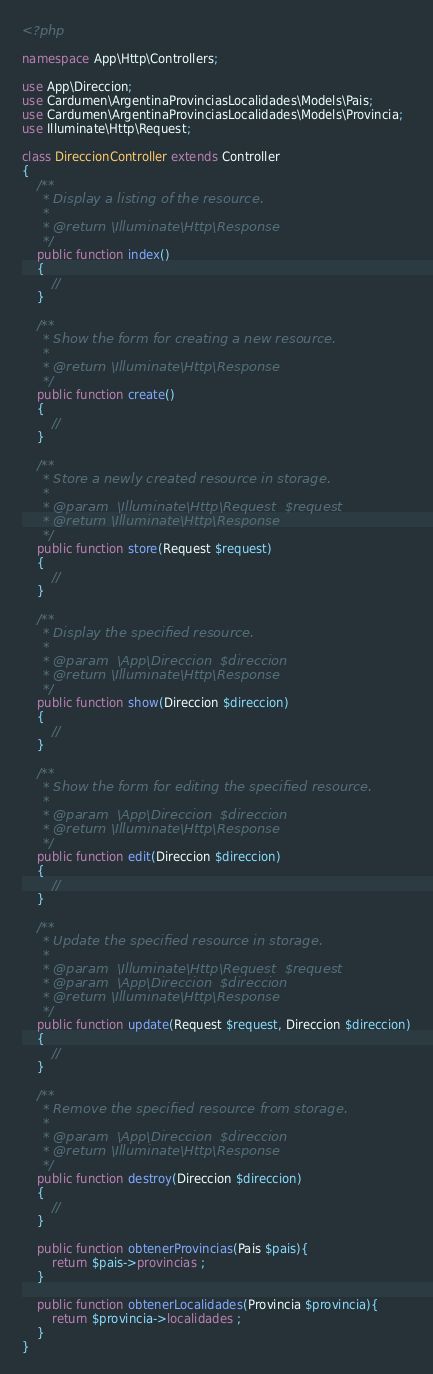Convert code to text. <code><loc_0><loc_0><loc_500><loc_500><_PHP_><?php

namespace App\Http\Controllers;

use App\Direccion;
use Cardumen\ArgentinaProvinciasLocalidades\Models\Pais;
use Cardumen\ArgentinaProvinciasLocalidades\Models\Provincia;
use Illuminate\Http\Request;

class DireccionController extends Controller
{
    /**
     * Display a listing of the resource.
     *
     * @return \Illuminate\Http\Response
     */
    public function index()
    {
        //
    }

    /**
     * Show the form for creating a new resource.
     *
     * @return \Illuminate\Http\Response
     */
    public function create()
    {
        //
    }

    /**
     * Store a newly created resource in storage.
     *
     * @param  \Illuminate\Http\Request  $request
     * @return \Illuminate\Http\Response
     */
    public function store(Request $request)
    {
        //
    }

    /**
     * Display the specified resource.
     *
     * @param  \App\Direccion  $direccion
     * @return \Illuminate\Http\Response
     */
    public function show(Direccion $direccion)
    {
        //
    }

    /**
     * Show the form for editing the specified resource.
     *
     * @param  \App\Direccion  $direccion
     * @return \Illuminate\Http\Response
     */
    public function edit(Direccion $direccion)
    {
        //
    }

    /**
     * Update the specified resource in storage.
     *
     * @param  \Illuminate\Http\Request  $request
     * @param  \App\Direccion  $direccion
     * @return \Illuminate\Http\Response
     */
    public function update(Request $request, Direccion $direccion)
    {
        //
    }

    /**
     * Remove the specified resource from storage.
     *
     * @param  \App\Direccion  $direccion
     * @return \Illuminate\Http\Response
     */
    public function destroy(Direccion $direccion)
    {
        //
    }

    public function obtenerProvincias(Pais $pais){
        return $pais->provincias ;
    }

    public function obtenerLocalidades(Provincia $provincia){
        return $provincia->localidades ;
    }
}
</code> 